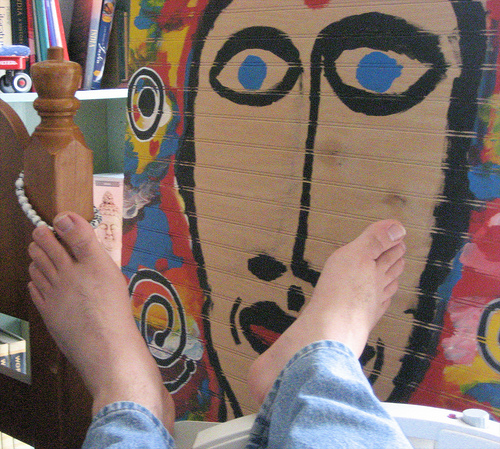<image>
Can you confirm if the painting is in front of the person? Yes. The painting is positioned in front of the person, appearing closer to the camera viewpoint. 